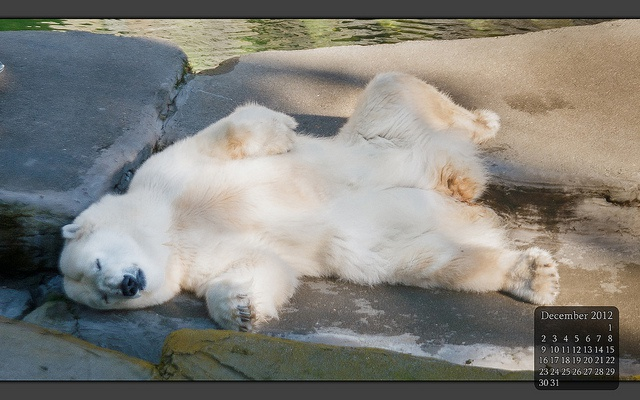Describe the objects in this image and their specific colors. I can see a bear in black, lightgray, darkgray, and tan tones in this image. 